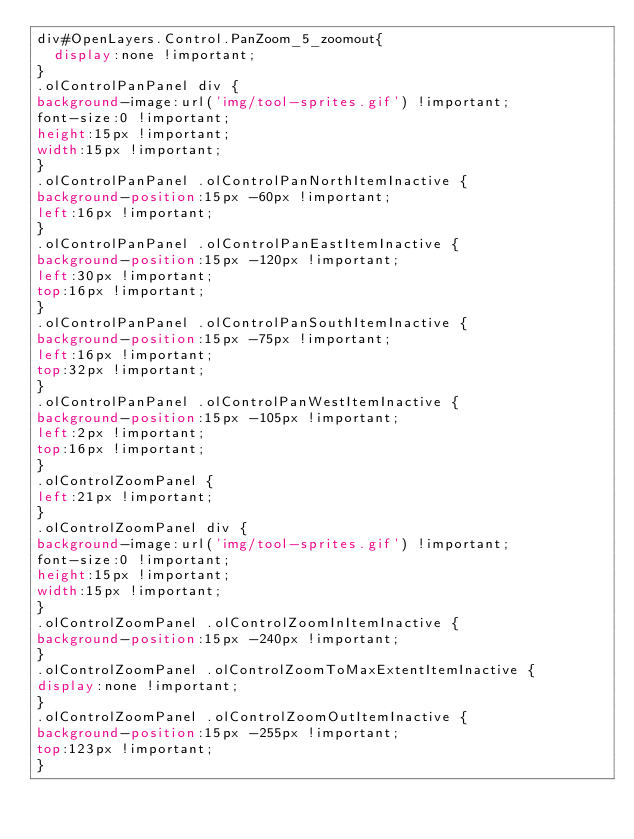<code> <loc_0><loc_0><loc_500><loc_500><_CSS_>div#OpenLayers.Control.PanZoom_5_zoomout{
	display:none !important;
}
.olControlPanPanel div {
background-image:url('img/tool-sprites.gif') !important;
font-size:0 !important;
height:15px !important;
width:15px !important;
}
.olControlPanPanel .olControlPanNorthItemInactive {
background-position:15px -60px !important;
left:16px !important;
}
.olControlPanPanel .olControlPanEastItemInactive {
background-position:15px -120px !important;
left:30px !important;
top:16px !important;
}
.olControlPanPanel .olControlPanSouthItemInactive {
background-position:15px -75px !important;
left:16px !important;
top:32px !important;
}
.olControlPanPanel .olControlPanWestItemInactive {
background-position:15px -105px !important;
left:2px !important;
top:16px !important;
}
.olControlZoomPanel {
left:21px !important;
}
.olControlZoomPanel div {
background-image:url('img/tool-sprites.gif') !important;
font-size:0 !important;
height:15px !important;
width:15px !important;
}
.olControlZoomPanel .olControlZoomInItemInactive {
background-position:15px -240px !important;
}
.olControlZoomPanel .olControlZoomToMaxExtentItemInactive {
display:none !important;
}
.olControlZoomPanel .olControlZoomOutItemInactive {
background-position:15px -255px !important;
top:123px !important;
}
</code> 